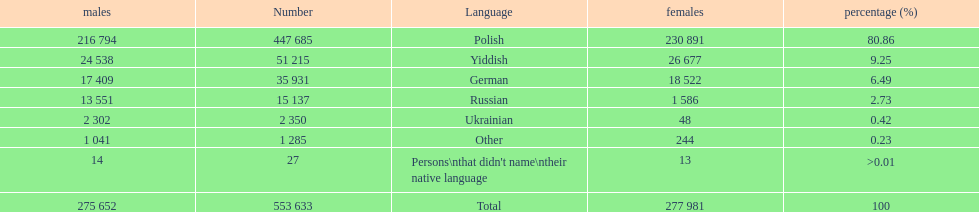Which language did the most people in the imperial census of 1897 speak in the p&#322;ock governorate? Polish. 